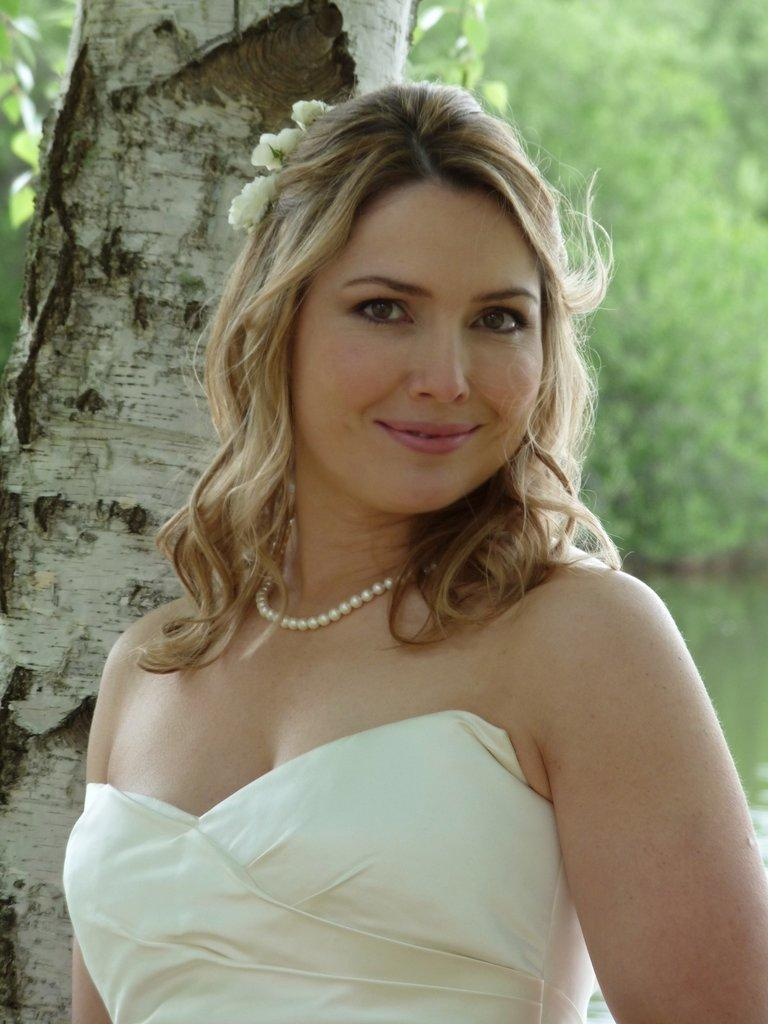Who or what is present in the image? There is a person in the image. What is the person wearing? The person is wearing a white dress. What can be seen in the background of the image? There are trees in the background of the image. What is the color of the trees? The trees are green in color. What type of organization is depicted in the image? There is no organization present in the image; it features a person wearing a white dress with green trees in the background. What kind of music is being played by the band in the image? There is no band present in the image, so it's not possible to determine what type of music might be played. 